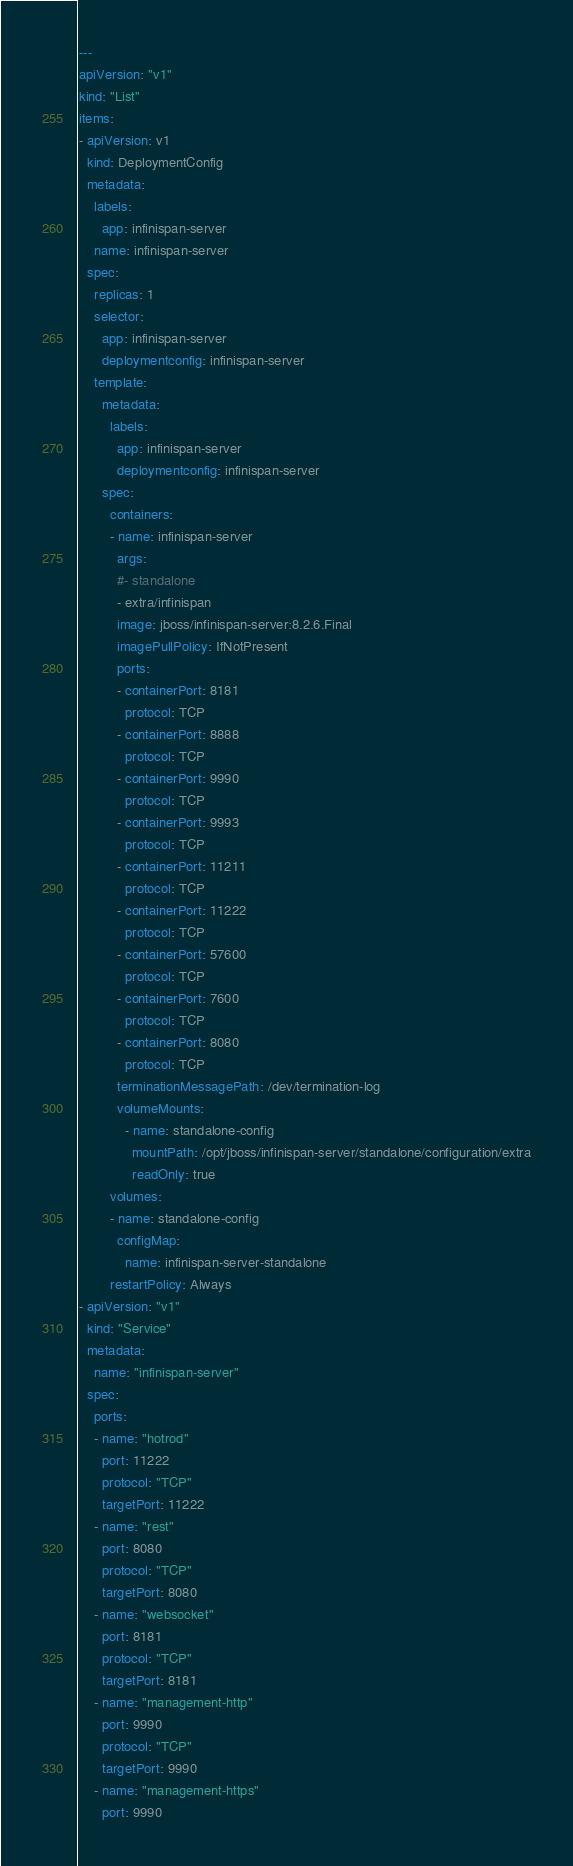<code> <loc_0><loc_0><loc_500><loc_500><_YAML_>---
apiVersion: "v1"
kind: "List"
items:
- apiVersion: v1
  kind: DeploymentConfig
  metadata:
    labels:
      app: infinispan-server
    name: infinispan-server
  spec:
    replicas: 1
    selector:
      app: infinispan-server
      deploymentconfig: infinispan-server
    template:
      metadata:
        labels:
          app: infinispan-server
          deploymentconfig: infinispan-server
      spec:
        containers:
        - name: infinispan-server
          args:
          #- standalone
          - extra/infinispan
          image: jboss/infinispan-server:8.2.6.Final
          imagePullPolicy: IfNotPresent          
          ports:
          - containerPort: 8181
            protocol: TCP
          - containerPort: 8888
            protocol: TCP
          - containerPort: 9990
            protocol: TCP
          - containerPort: 9993
            protocol: TCP
          - containerPort: 11211
            protocol: TCP
          - containerPort: 11222
            protocol: TCP
          - containerPort: 57600
            protocol: TCP
          - containerPort: 7600
            protocol: TCP
          - containerPort: 8080
            protocol: TCP
          terminationMessagePath: /dev/termination-log
          volumeMounts:
            - name: standalone-config
              mountPath: /opt/jboss/infinispan-server/standalone/configuration/extra
              readOnly: true
        volumes:
        - name: standalone-config
          configMap:
            name: infinispan-server-standalone
        restartPolicy: Always
- apiVersion: "v1"
  kind: "Service"
  metadata:
    name: "infinispan-server"
  spec:
    ports:
    - name: "hotrod"
      port: 11222
      protocol: "TCP"
      targetPort: 11222
    - name: "rest"
      port: 8080
      protocol: "TCP"
      targetPort: 8080
    - name: "websocket"
      port: 8181
      protocol: "TCP"
      targetPort: 8181
    - name: "management-http"
      port: 9990
      protocol: "TCP"
      targetPort: 9990
    - name: "management-https"
      port: 9990</code> 